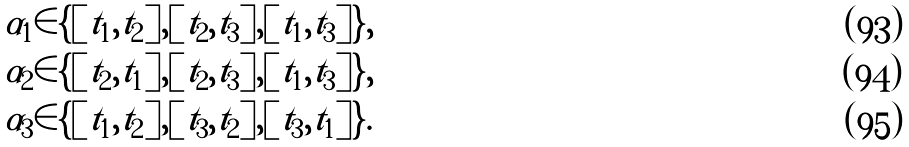Convert formula to latex. <formula><loc_0><loc_0><loc_500><loc_500>& \alpha _ { 1 } \in \{ [ t _ { 1 } , t _ { 2 } ] , [ t _ { 2 } , t _ { 3 } ] , [ t _ { 1 } , t _ { 3 } ] \} , \\ & \alpha _ { 2 } \in \{ [ t _ { 2 } , t _ { 1 } ] , [ t _ { 2 } , t _ { 3 } ] , [ t _ { 1 } , t _ { 3 } ] \} , \\ & \alpha _ { 3 } \in \{ [ t _ { 1 } , t _ { 2 } ] , [ t _ { 3 } , t _ { 2 } ] , [ t _ { 3 } , t _ { 1 } ] \} .</formula> 